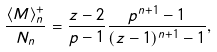Convert formula to latex. <formula><loc_0><loc_0><loc_500><loc_500>\frac { \langle M \rangle _ { n } ^ { + } } { N _ { n } } = \frac { z - 2 } { p - 1 } \frac { p ^ { n + 1 } - 1 } { ( z - 1 ) ^ { n + 1 } - 1 } ,</formula> 